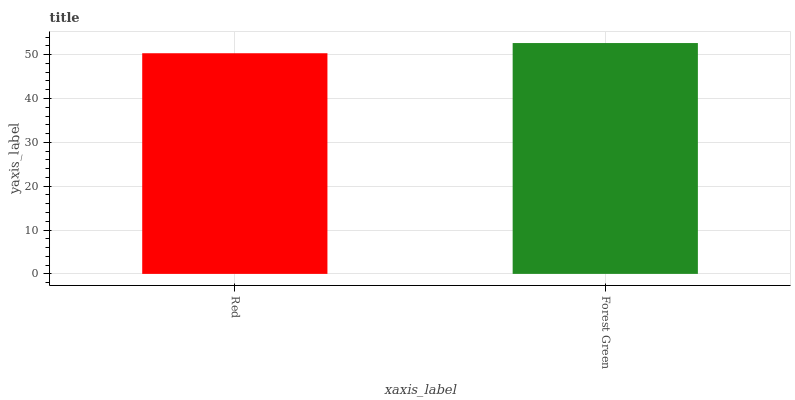Is Red the minimum?
Answer yes or no. Yes. Is Forest Green the maximum?
Answer yes or no. Yes. Is Forest Green the minimum?
Answer yes or no. No. Is Forest Green greater than Red?
Answer yes or no. Yes. Is Red less than Forest Green?
Answer yes or no. Yes. Is Red greater than Forest Green?
Answer yes or no. No. Is Forest Green less than Red?
Answer yes or no. No. Is Forest Green the high median?
Answer yes or no. Yes. Is Red the low median?
Answer yes or no. Yes. Is Red the high median?
Answer yes or no. No. Is Forest Green the low median?
Answer yes or no. No. 